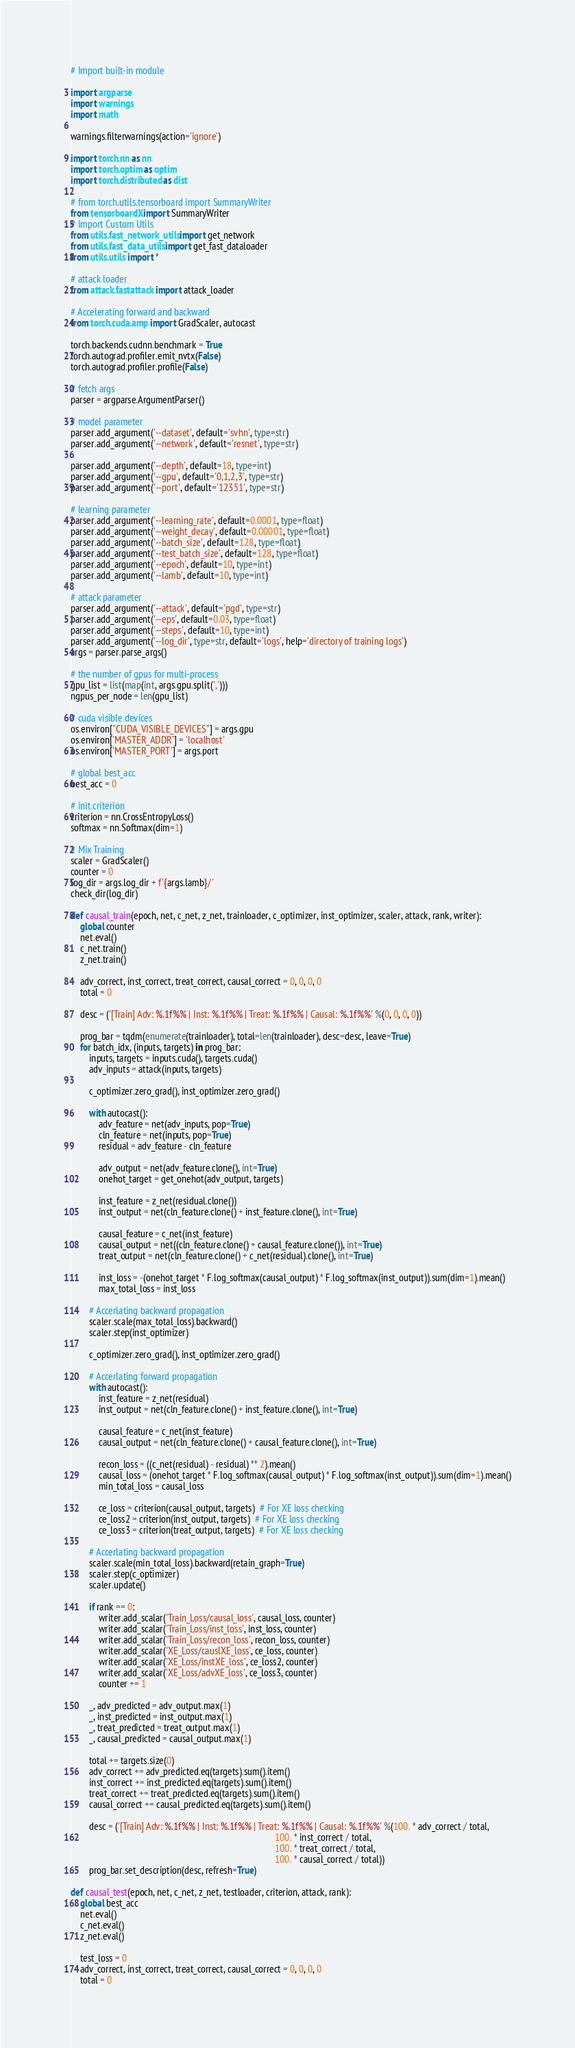<code> <loc_0><loc_0><loc_500><loc_500><_Python_># Import built-in module

import argparse
import warnings
import math

warnings.filterwarnings(action='ignore')

import torch.nn as nn
import torch.optim as optim
import torch.distributed as dist

# from torch.utils.tensorboard import SummaryWriter
from tensorboardX import SummaryWriter
# Import Custom Utils
from utils.fast_network_utils import get_network
from utils.fast_data_utils import get_fast_dataloader
from utils.utils import *

# attack loader
from attack.fastattack import attack_loader

# Accelerating forward and backward
from torch.cuda.amp import GradScaler, autocast

torch.backends.cudnn.benchmark = True
torch.autograd.profiler.emit_nvtx(False)
torch.autograd.profiler.profile(False)

# fetch args
parser = argparse.ArgumentParser()

# model parameter
parser.add_argument('--dataset', default='svhn', type=str)
parser.add_argument('--network', default='resnet', type=str)

parser.add_argument('--depth', default=18, type=int)
parser.add_argument('--gpu', default='0,1,2,3', type=str)
parser.add_argument('--port', default='12351', type=str)

# learning parameter
parser.add_argument('--learning_rate', default=0.0001, type=float)
parser.add_argument('--weight_decay', default=0.00001, type=float)
parser.add_argument('--batch_size', default=128, type=float)
parser.add_argument('--test_batch_size', default=128, type=float)
parser.add_argument('--epoch', default=10, type=int)
parser.add_argument('--lamb', default=10, type=int)

# attack parameter
parser.add_argument('--attack', default='pgd', type=str)
parser.add_argument('--eps', default=0.03, type=float)
parser.add_argument('--steps', default=10, type=int)
parser.add_argument('--log_dir', type=str, default='logs', help='directory of training logs')
args = parser.parse_args()

# the number of gpus for multi-process
gpu_list = list(map(int, args.gpu.split(',')))
ngpus_per_node = len(gpu_list)

# cuda visible devices
os.environ["CUDA_VISIBLE_DEVICES"] = args.gpu
os.environ['MASTER_ADDR'] = 'localhost'
os.environ['MASTER_PORT'] = args.port

# global best_acc
best_acc = 0

# init criterion
criterion = nn.CrossEntropyLoss()
softmax = nn.Softmax(dim=1)

# Mix Training
scaler = GradScaler()
counter = 0
log_dir = args.log_dir + f'{args.lamb}/'
check_dir(log_dir)

def causal_train(epoch, net, c_net, z_net, trainloader, c_optimizer, inst_optimizer, scaler, attack, rank, writer):
    global counter
    net.eval()
    c_net.train()
    z_net.train()

    adv_correct, inst_correct, treat_correct, causal_correct = 0, 0, 0, 0
    total = 0

    desc = ('[Train] Adv: %.1f%% | Inst: %.1f%% | Treat: %.1f%% | Causal: %.1f%%' %(0, 0, 0, 0))

    prog_bar = tqdm(enumerate(trainloader), total=len(trainloader), desc=desc, leave=True)
    for batch_idx, (inputs, targets) in prog_bar:
        inputs, targets = inputs.cuda(), targets.cuda()
        adv_inputs = attack(inputs, targets)

        c_optimizer.zero_grad(), inst_optimizer.zero_grad()

        with autocast():
            adv_feature = net(adv_inputs, pop=True)
            cln_feature = net(inputs, pop=True)
            residual = adv_feature - cln_feature

            adv_output = net(adv_feature.clone(), int=True)
            onehot_target = get_onehot(adv_output, targets)

            inst_feature = z_net(residual.clone())
            inst_output = net(cln_feature.clone() + inst_feature.clone(), int=True)

            causal_feature = c_net(inst_feature)
            causal_output = net((cln_feature.clone() + causal_feature.clone()), int=True)
            treat_output = net(cln_feature.clone() + c_net(residual).clone(), int=True)

            inst_loss = -(onehot_target * F.log_softmax(causal_output) * F.log_softmax(inst_output)).sum(dim=1).mean()
            max_total_loss = inst_loss

        # Accerlating backward propagation
        scaler.scale(max_total_loss).backward()
        scaler.step(inst_optimizer)

        c_optimizer.zero_grad(), inst_optimizer.zero_grad()

        # Accerlating forward propagation
        with autocast():
            inst_feature = z_net(residual)
            inst_output = net(cln_feature.clone() + inst_feature.clone(), int=True)

            causal_feature = c_net(inst_feature)
            causal_output = net(cln_feature.clone() + causal_feature.clone(), int=True)

            recon_loss = ((c_net(residual) - residual) ** 2).mean()
            causal_loss = (onehot_target * F.log_softmax(causal_output) * F.log_softmax(inst_output)).sum(dim=1).mean()
            min_total_loss = causal_loss

            ce_loss = criterion(causal_output, targets)  # For XE loss checking
            ce_loss2 = criterion(inst_output, targets)  # For XE loss checking
            ce_loss3 = criterion(treat_output, targets)  # For XE loss checking

        # Accerlating backward propagation
        scaler.scale(min_total_loss).backward(retain_graph=True)
        scaler.step(c_optimizer)
        scaler.update()

        if rank == 0:
            writer.add_scalar('Train_Loss/causal_loss', causal_loss, counter)
            writer.add_scalar('Train_Loss/inst_loss', inst_loss, counter)
            writer.add_scalar('Train_Loss/recon_loss', recon_loss, counter)
            writer.add_scalar('XE_Loss/causlXE_loss', ce_loss, counter)
            writer.add_scalar('XE_Loss/instXE_loss', ce_loss2, counter)
            writer.add_scalar('XE_Loss/advXE_loss', ce_loss3, counter)
            counter += 1

        _, adv_predicted = adv_output.max(1)
        _, inst_predicted = inst_output.max(1)
        _, treat_predicted = treat_output.max(1)
        _, causal_predicted = causal_output.max(1)

        total += targets.size(0)
        adv_correct += adv_predicted.eq(targets).sum().item()
        inst_correct += inst_predicted.eq(targets).sum().item()
        treat_correct += treat_predicted.eq(targets).sum().item()
        causal_correct += causal_predicted.eq(targets).sum().item()

        desc = ('[Train] Adv: %.1f%% | Inst: %.1f%% | Treat: %.1f%% | Causal: %.1f%%' %(100. * adv_correct / total,
                                                                                        100. * inst_correct / total,
                                                                                        100. * treat_correct / total,
                                                                                        100. * causal_correct / total))
        prog_bar.set_description(desc, refresh=True)

def causal_test(epoch, net, c_net, z_net, testloader, criterion, attack, rank):
    global best_acc
    net.eval()
    c_net.eval()
    z_net.eval()

    test_loss = 0
    adv_correct, inst_correct, treat_correct, causal_correct = 0, 0, 0, 0
    total = 0
</code> 